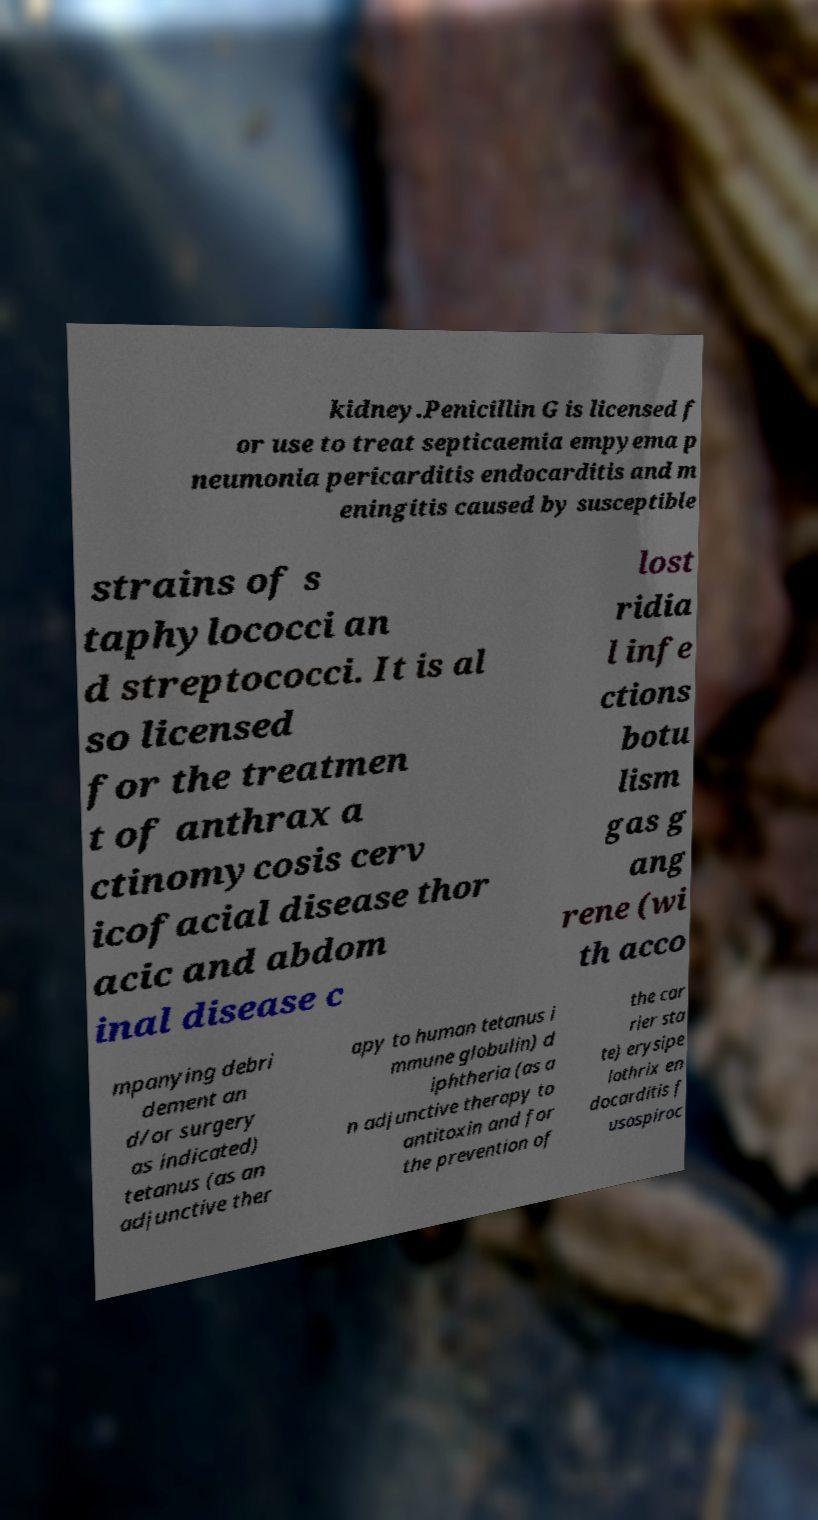What messages or text are displayed in this image? I need them in a readable, typed format. kidney.Penicillin G is licensed f or use to treat septicaemia empyema p neumonia pericarditis endocarditis and m eningitis caused by susceptible strains of s taphylococci an d streptococci. It is al so licensed for the treatmen t of anthrax a ctinomycosis cerv icofacial disease thor acic and abdom inal disease c lost ridia l infe ctions botu lism gas g ang rene (wi th acco mpanying debri dement an d/or surgery as indicated) tetanus (as an adjunctive ther apy to human tetanus i mmune globulin) d iphtheria (as a n adjunctive therapy to antitoxin and for the prevention of the car rier sta te) erysipe lothrix en docarditis f usospiroc 